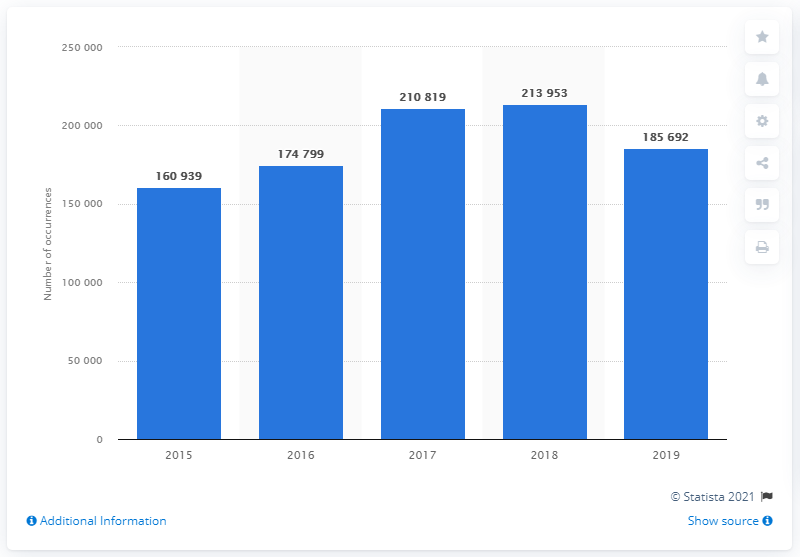Give some essential details in this illustration. In 2019, a total of 185,692 vehicles were reported to have been robbed in Mexico. In 2018, a total of 213,953 vehicles were reported to have been robbed in Mexico. 